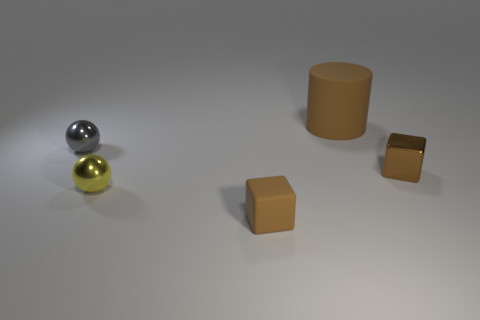Add 5 cylinders. How many objects exist? 10 Subtract all cylinders. How many objects are left? 4 Subtract all small brown things. Subtract all large cyan rubber spheres. How many objects are left? 3 Add 2 gray balls. How many gray balls are left? 3 Add 2 brown cubes. How many brown cubes exist? 4 Subtract 0 blue blocks. How many objects are left? 5 